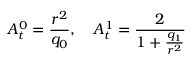Convert formula to latex. <formula><loc_0><loc_0><loc_500><loc_500>A _ { t } ^ { 0 } = \frac { r ^ { 2 } } { q _ { 0 } } , \quad A _ { t } ^ { 1 } = \frac { 2 } { 1 + \frac { q _ { 1 } } { r ^ { 2 } } }</formula> 